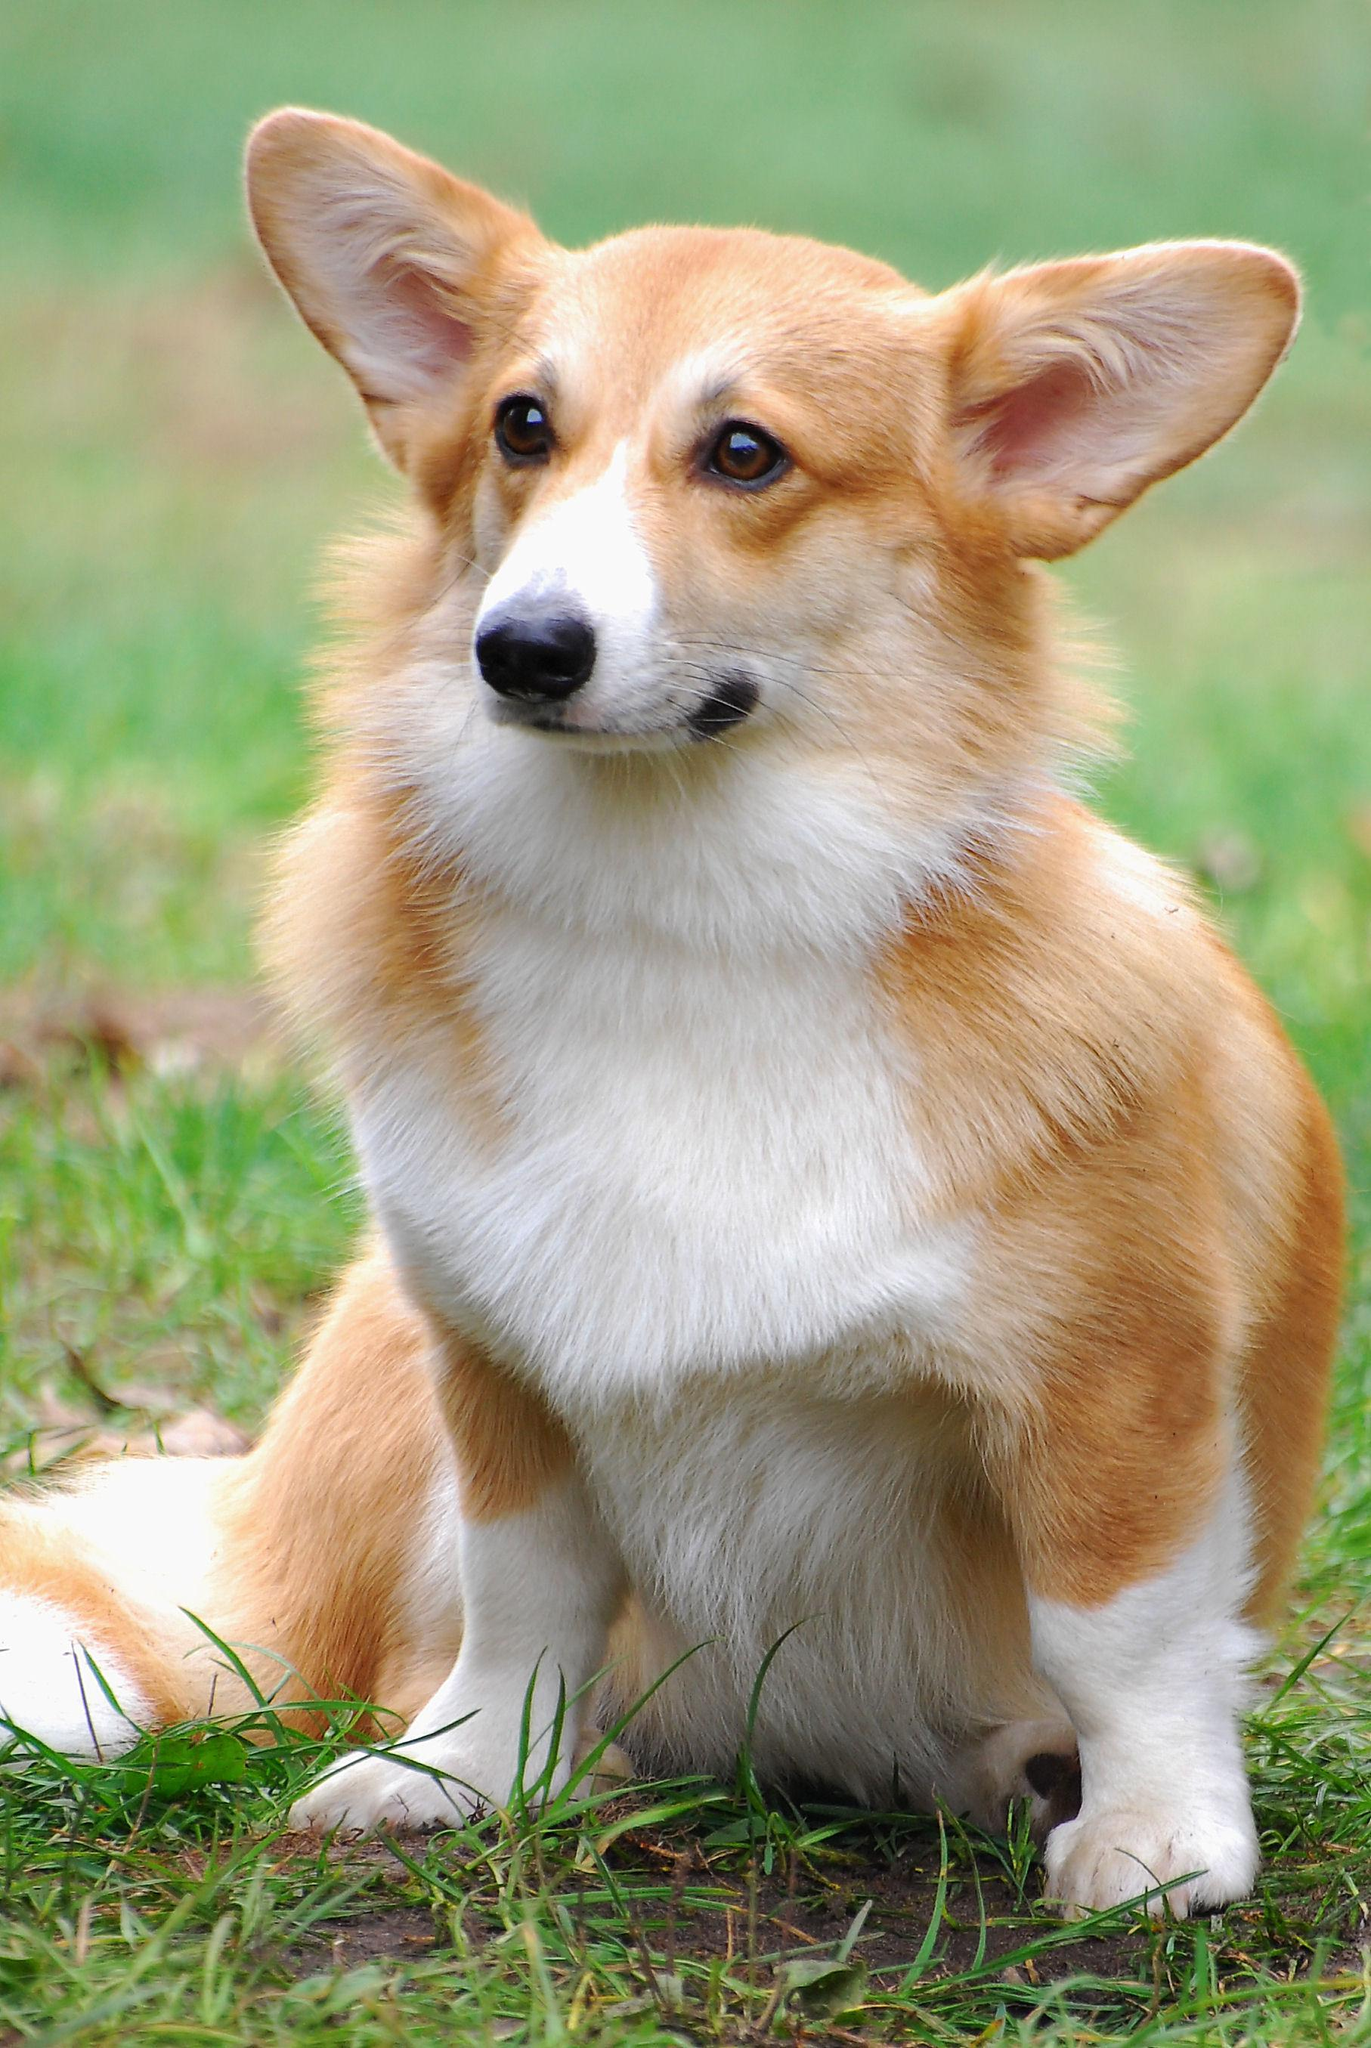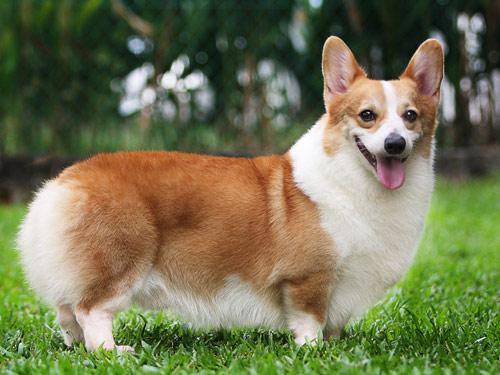The first image is the image on the left, the second image is the image on the right. Assess this claim about the two images: "There are two dogs and neither of them have any black fur.". Correct or not? Answer yes or no. Yes. The first image is the image on the left, the second image is the image on the right. Assess this claim about the two images: "An image shows one short-legged dog standing in profile on green grass, with its face turned to the camera.". Correct or not? Answer yes or no. Yes. The first image is the image on the left, the second image is the image on the right. For the images shown, is this caption "An image shows one orange-and-white dog, which wears a collar with a blue doggie bone-shaped charm." true? Answer yes or no. No. 